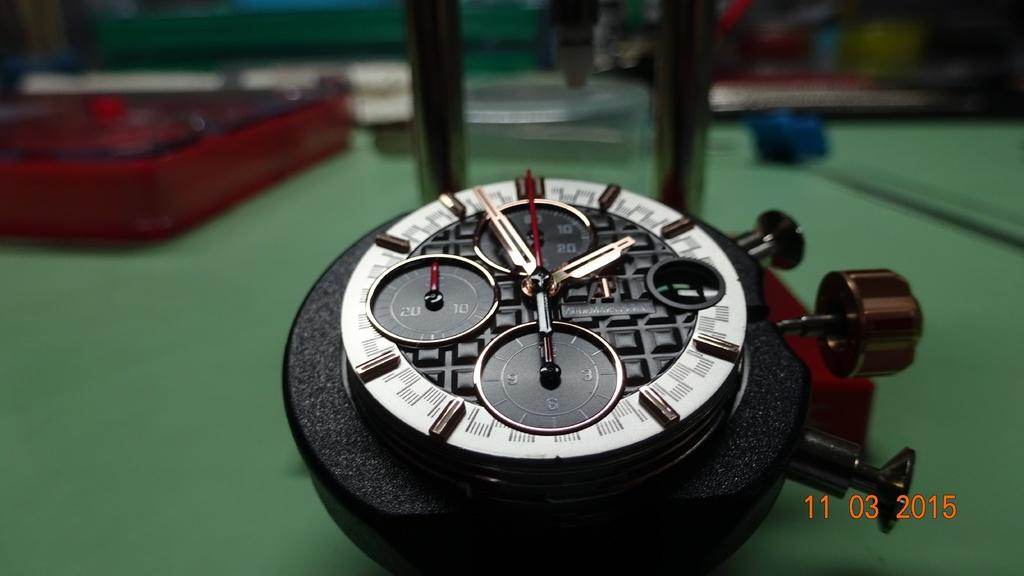What type of watch is visible in the image? There is an analog watch in the image. What objects are placed on a surface in the image? Tables are placed on a surface in the image. Can you describe the numbers visible in the bottom right corner of the image? The numbers visible in the bottom right corner of the image are not clear enough to identify. How many forks are resting on the tables in the image? There are no forks visible in the image; only tables and an analog watch are present. What achievements can be attributed to the person in the image? There is no person present in the image, so it is impossible to determine any achievements. 